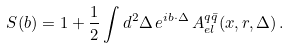<formula> <loc_0><loc_0><loc_500><loc_500>S ( b ) = 1 + \frac { 1 } { 2 } \int d ^ { 2 } \Delta \, e ^ { i { b } \cdot { \Delta } } \, A _ { e l } ^ { q \bar { q } } ( x , r , \Delta ) \, .</formula> 